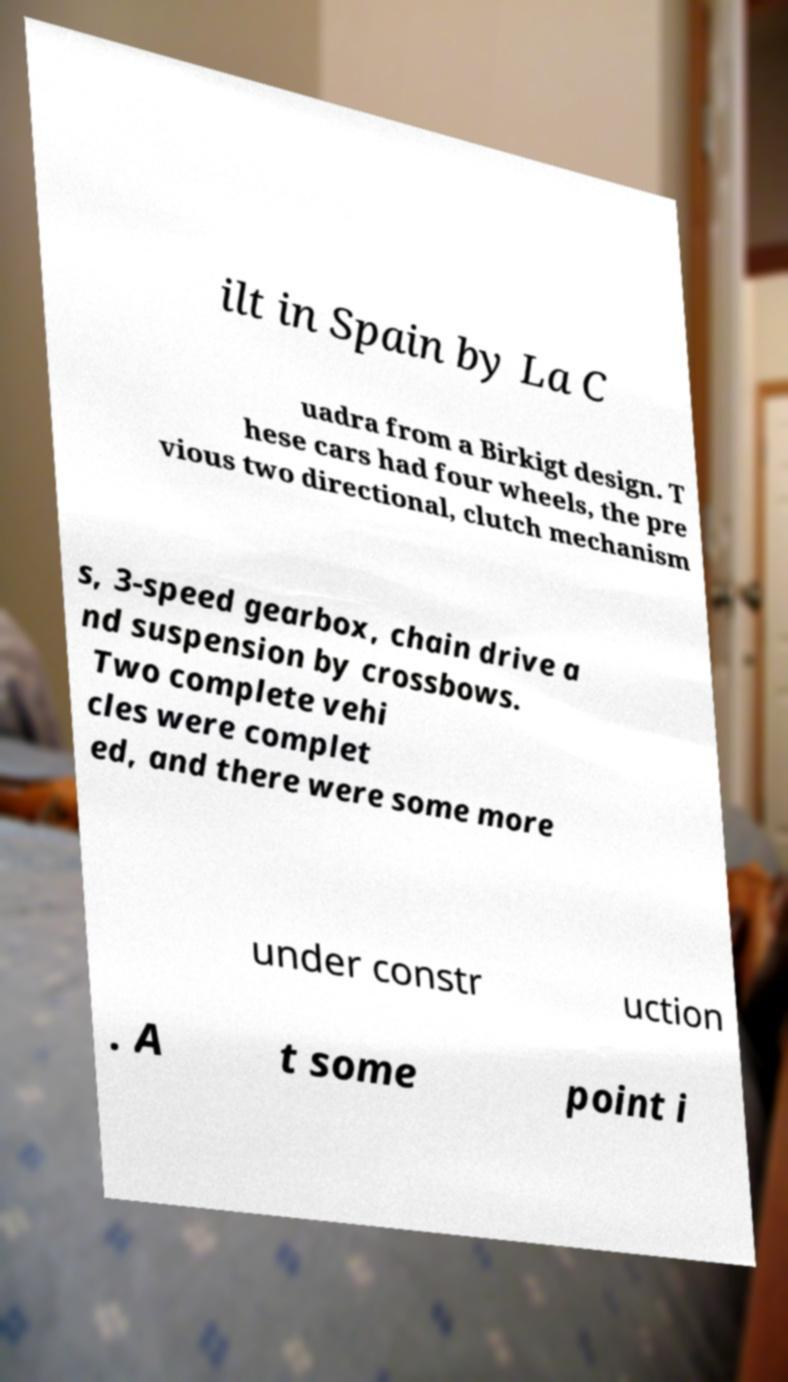Please identify and transcribe the text found in this image. ilt in Spain by La C uadra from a Birkigt design. T hese cars had four wheels, the pre vious two directional, clutch mechanism s, 3-speed gearbox, chain drive a nd suspension by crossbows. Two complete vehi cles were complet ed, and there were some more under constr uction . A t some point i 